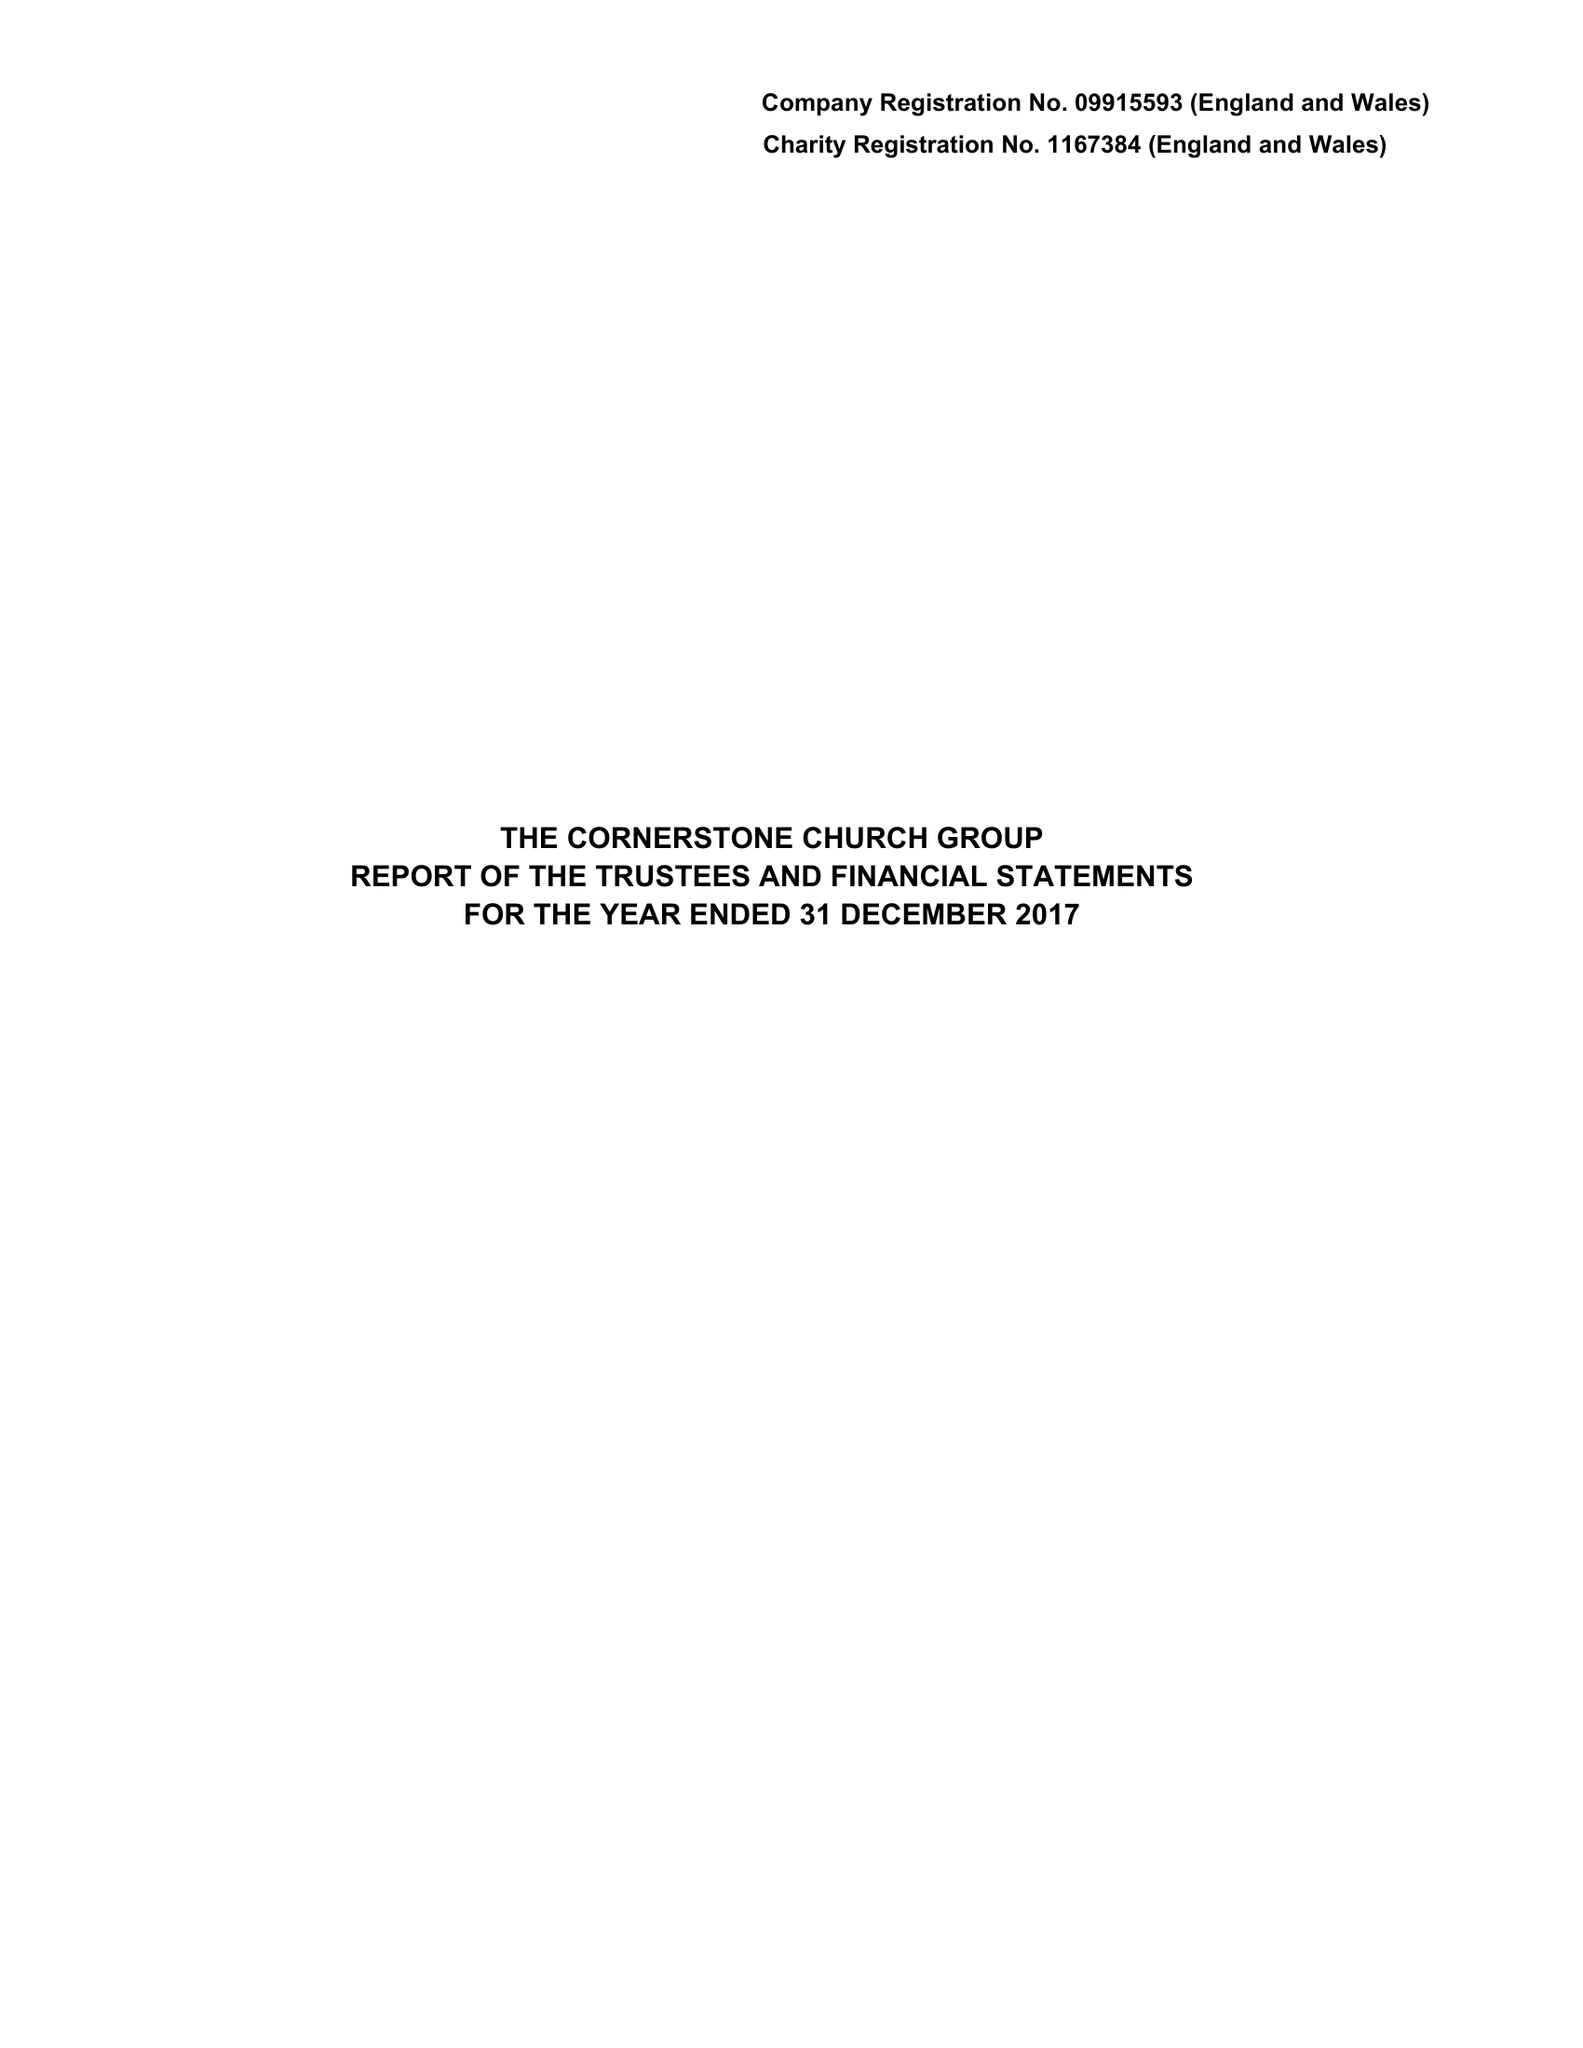What is the value for the address__street_line?
Answer the question using a single word or phrase. 86-90 PAUL STREET 